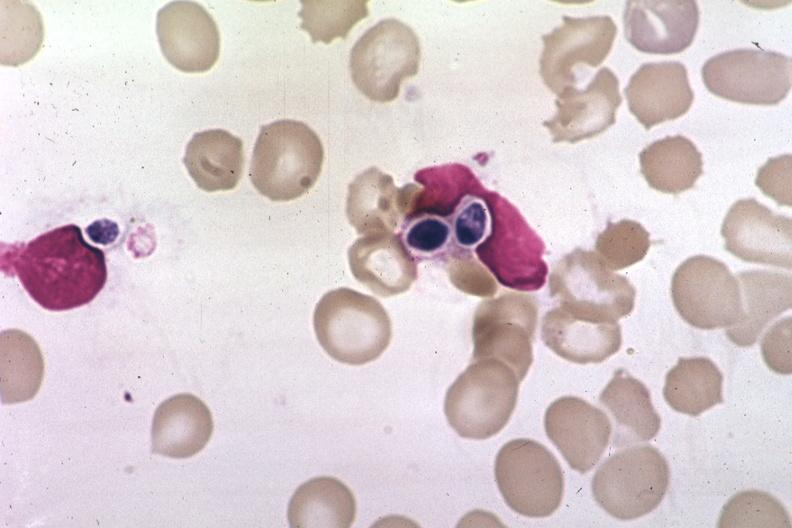what does this image show?
Answer the question using a single word or phrase. Wrights 